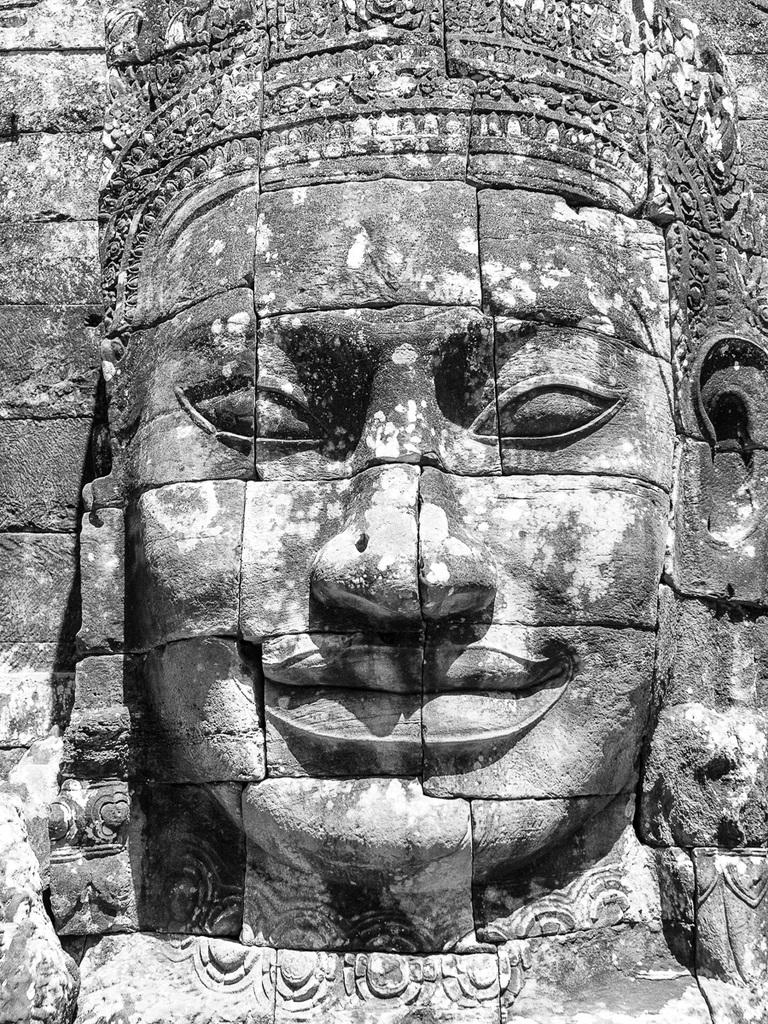What is the main subject of the image? The main subject of the image is a person's face engraved on a rock. Can you describe the texture of the rock in the image? The texture of the rock cannot be determined from the image alone, but it appears to be a solid surface with the engraving of a face. What might be the purpose of engraving a face on the rock? The purpose of engraving a face on the rock could be for artistic expression, commemoration, or historical significance. What type of feather can be seen floating in the ocean in the image? There is no feather or ocean present in the image; it features a person's face engraved on a rock. How many bikes are visible in the image? There are no bikes present in the image; it features a person's face engraved on a rock. 